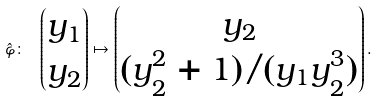<formula> <loc_0><loc_0><loc_500><loc_500>\hat { \varphi } \colon \ \begin{pmatrix} y _ { 1 } \\ y _ { 2 } \end{pmatrix} \mapsto \begin{pmatrix} y _ { 2 } \\ ( y _ { 2 } ^ { 2 } + 1 ) / ( y _ { 1 } y _ { 2 } ^ { 3 } ) \end{pmatrix} .</formula> 